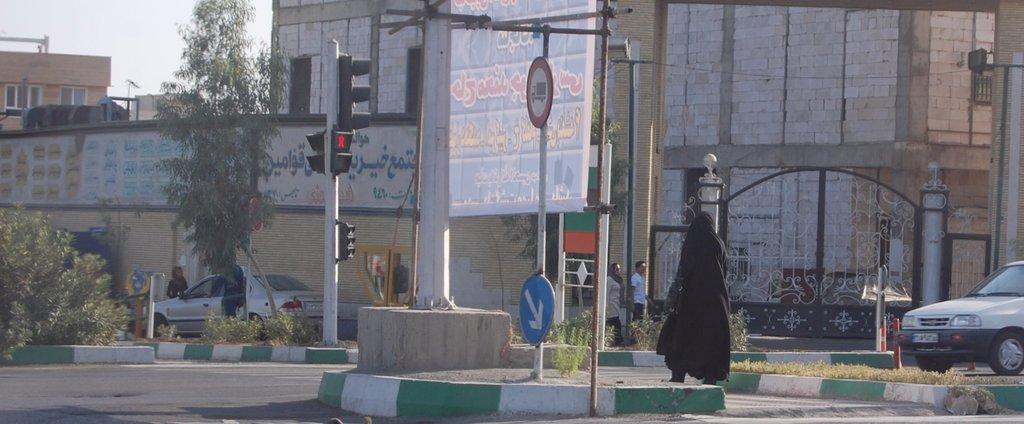Could you give a brief overview of what you see in this image? In the foreground of the image, we can see banner, poles, signal lights and a person. In the background, we can see trees, cars, gate, board, plants, people and buildings. In the left top of the image, we can see the sky. 